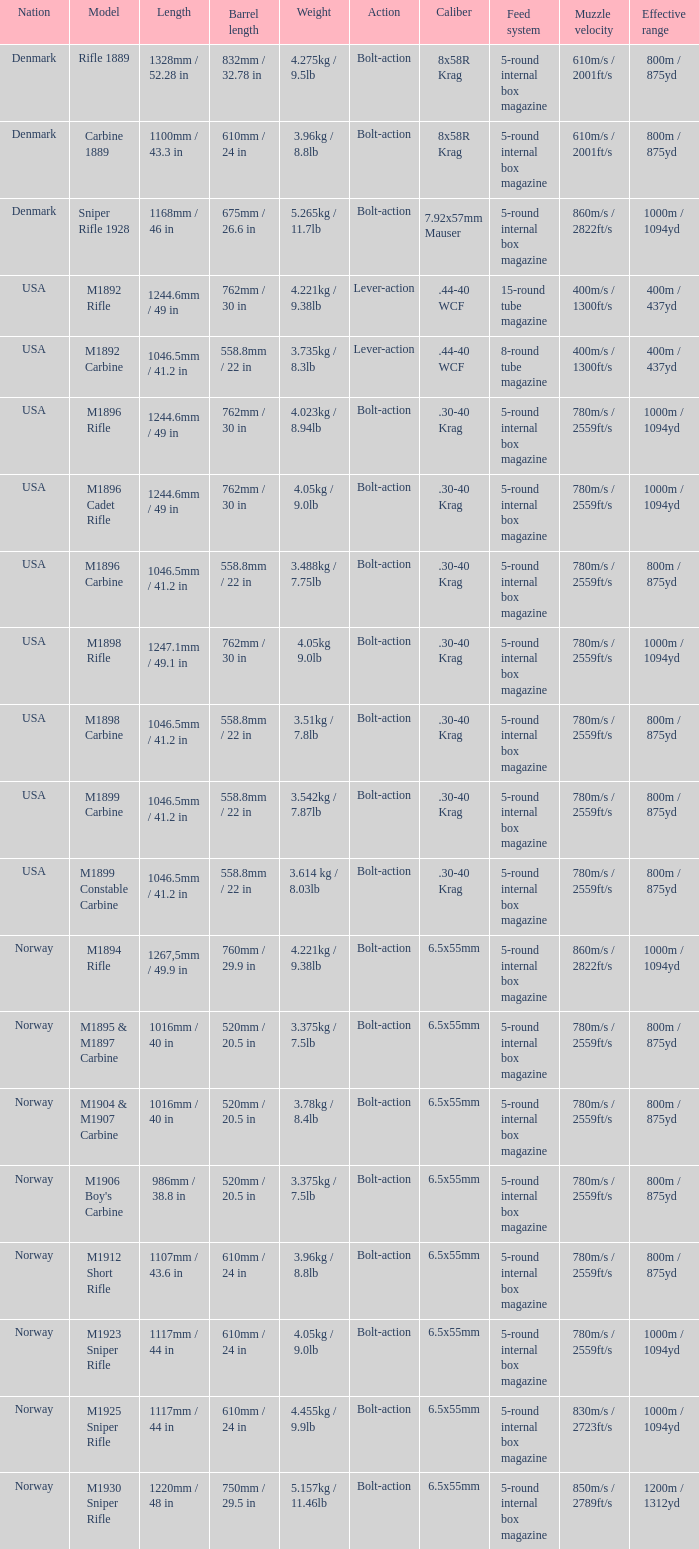How long is the length, given that the barrel length is 750mm or 29.5 inches? 1220mm / 48 in. 